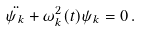<formula> <loc_0><loc_0><loc_500><loc_500>\ddot { \psi _ { k } } + \omega ^ { 2 } _ { k } ( t ) \psi _ { k } = 0 \, .</formula> 